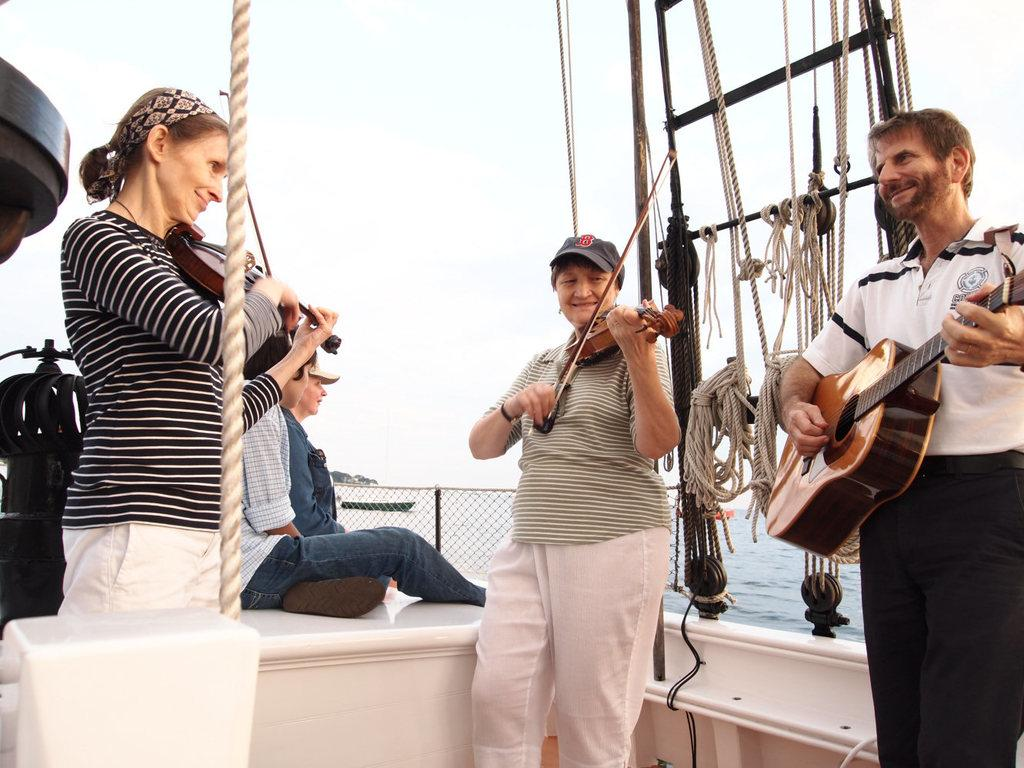What can be seen in the sky in the image? There is sky visible in the image. What is located near the sky in the image? There is water visible in the image. What is separating the sky and water in the image? There is a fence in the image. How many people are in the image, and what are they doing? There are three people in the image, and each of them is holding a guitar. What type of lawyer is standing next to the grandmother in the image? There is no lawyer or grandmother present in the image. What is the earth doing in the image? The earth is not present in the image; it is a planet and not visible in this context. 